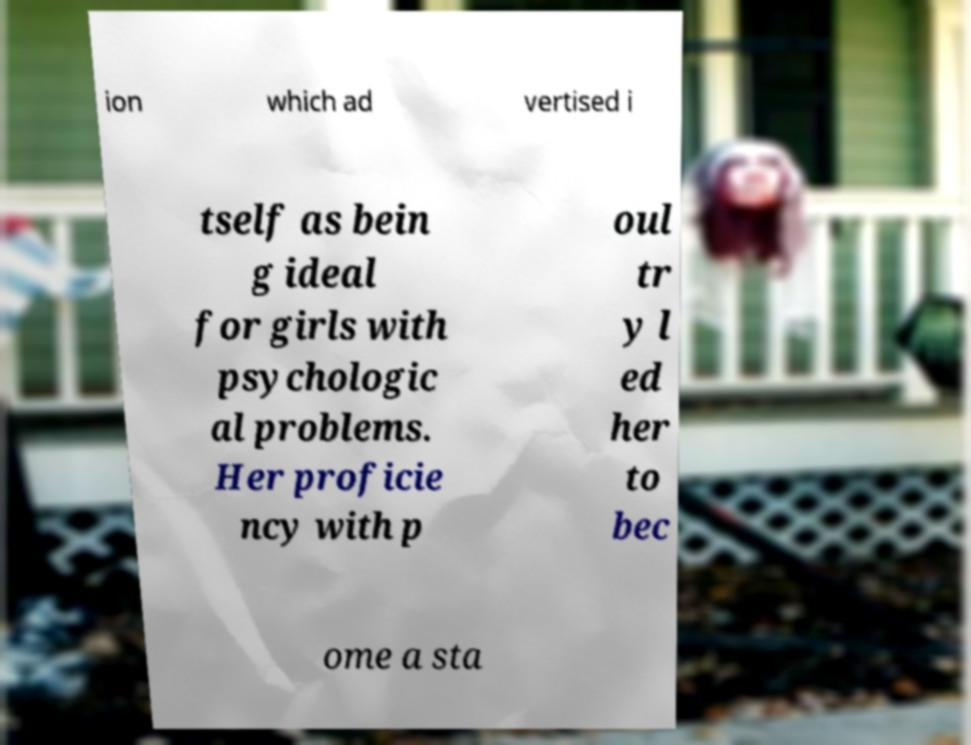Please identify and transcribe the text found in this image. ion which ad vertised i tself as bein g ideal for girls with psychologic al problems. Her proficie ncy with p oul tr y l ed her to bec ome a sta 